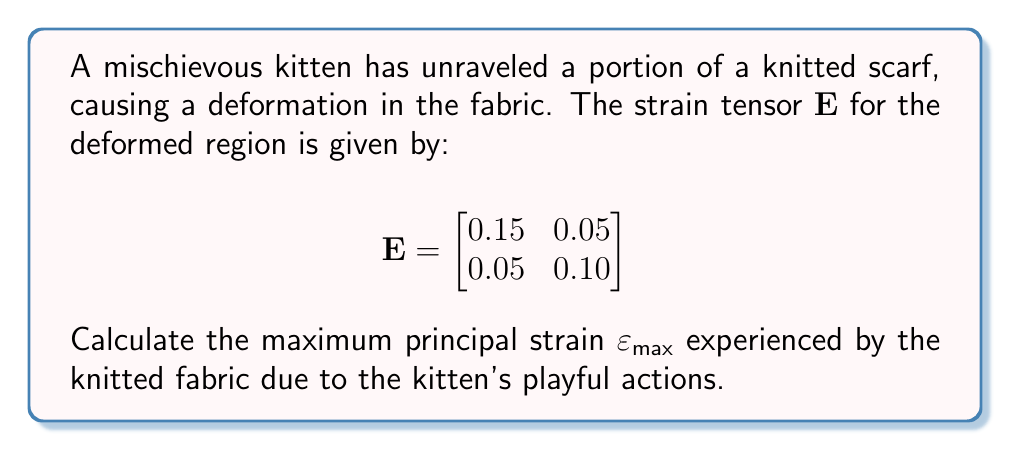Can you solve this math problem? To find the maximum principal strain, we need to follow these steps:

1) The principal strains are the eigenvalues of the strain tensor $\mathbf{E}$.

2) To find the eigenvalues, we solve the characteristic equation:
   $\det(\mathbf{E} - \lambda \mathbf{I}) = 0$

3) Expanding this:
   $$\begin{vmatrix}
   0.15 - \lambda & 0.05 \\
   0.05 & 0.10 - \lambda
   \end{vmatrix} = 0$$

4) This gives us:
   $(0.15 - \lambda)(0.10 - \lambda) - (0.05)(0.05) = 0$

5) Simplifying:
   $\lambda^2 - 0.25\lambda + 0.0125 = 0$

6) Using the quadratic formula $\lambda = \frac{-b \pm \sqrt{b^2 - 4ac}}{2a}$:
   
   $\lambda = \frac{0.25 \pm \sqrt{0.25^2 - 4(1)(0.0125)}}{2(1)}$

7) Simplifying:
   $\lambda = \frac{0.25 \pm \sqrt{0.0625 - 0.05}}{2} = \frac{0.25 \pm \sqrt{0.0125}}{2}$

8) This gives us two eigenvalues:
   $\lambda_1 = \frac{0.25 + \sqrt{0.0125}}{2} \approx 0.1806$
   $\lambda_2 = \frac{0.25 - \sqrt{0.0125}}{2} \approx 0.0694$

9) The maximum principal strain $\varepsilon_{max}$ is the larger of these two values.
Answer: $\varepsilon_{max} \approx 0.1806$ 